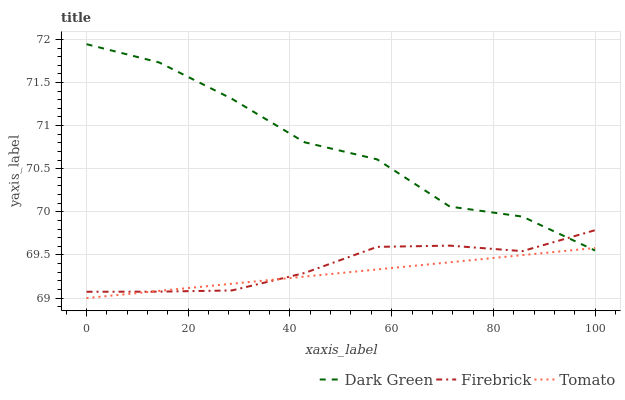Does Tomato have the minimum area under the curve?
Answer yes or no. Yes. Does Dark Green have the maximum area under the curve?
Answer yes or no. Yes. Does Firebrick have the minimum area under the curve?
Answer yes or no. No. Does Firebrick have the maximum area under the curve?
Answer yes or no. No. Is Tomato the smoothest?
Answer yes or no. Yes. Is Dark Green the roughest?
Answer yes or no. Yes. Is Firebrick the smoothest?
Answer yes or no. No. Is Firebrick the roughest?
Answer yes or no. No. Does Tomato have the lowest value?
Answer yes or no. Yes. Does Firebrick have the lowest value?
Answer yes or no. No. Does Dark Green have the highest value?
Answer yes or no. Yes. Does Firebrick have the highest value?
Answer yes or no. No. Does Firebrick intersect Tomato?
Answer yes or no. Yes. Is Firebrick less than Tomato?
Answer yes or no. No. Is Firebrick greater than Tomato?
Answer yes or no. No. 